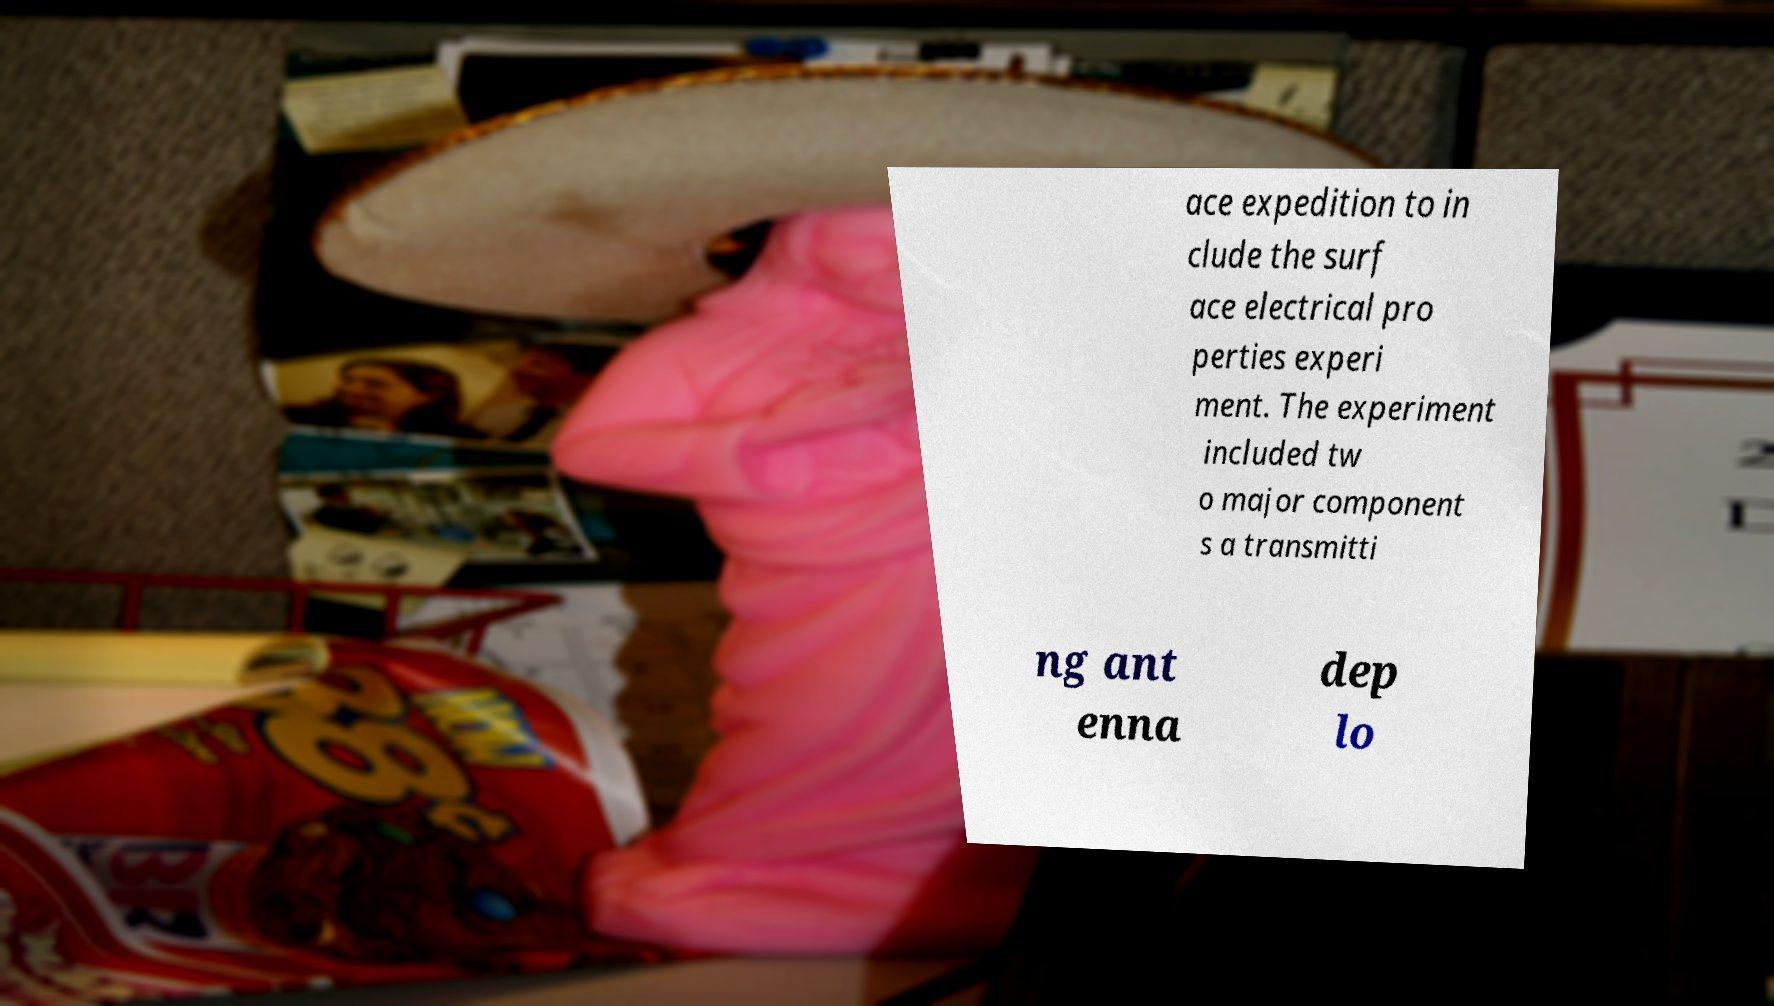Could you assist in decoding the text presented in this image and type it out clearly? ace expedition to in clude the surf ace electrical pro perties experi ment. The experiment included tw o major component s a transmitti ng ant enna dep lo 